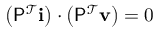Convert formula to latex. <formula><loc_0><loc_0><loc_500><loc_500>\left ( P ^ { \mathcal { T } } i \right ) \cdot \left ( P ^ { \mathcal { T } } v \right ) = 0</formula> 